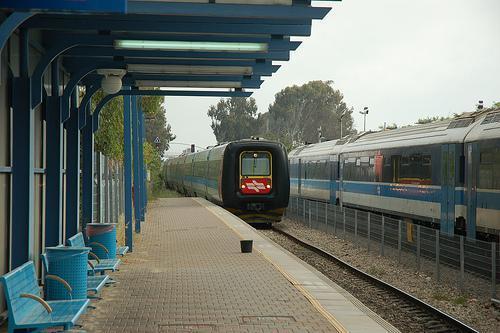How many garbage cans have a blue bag?
Give a very brief answer. 1. 